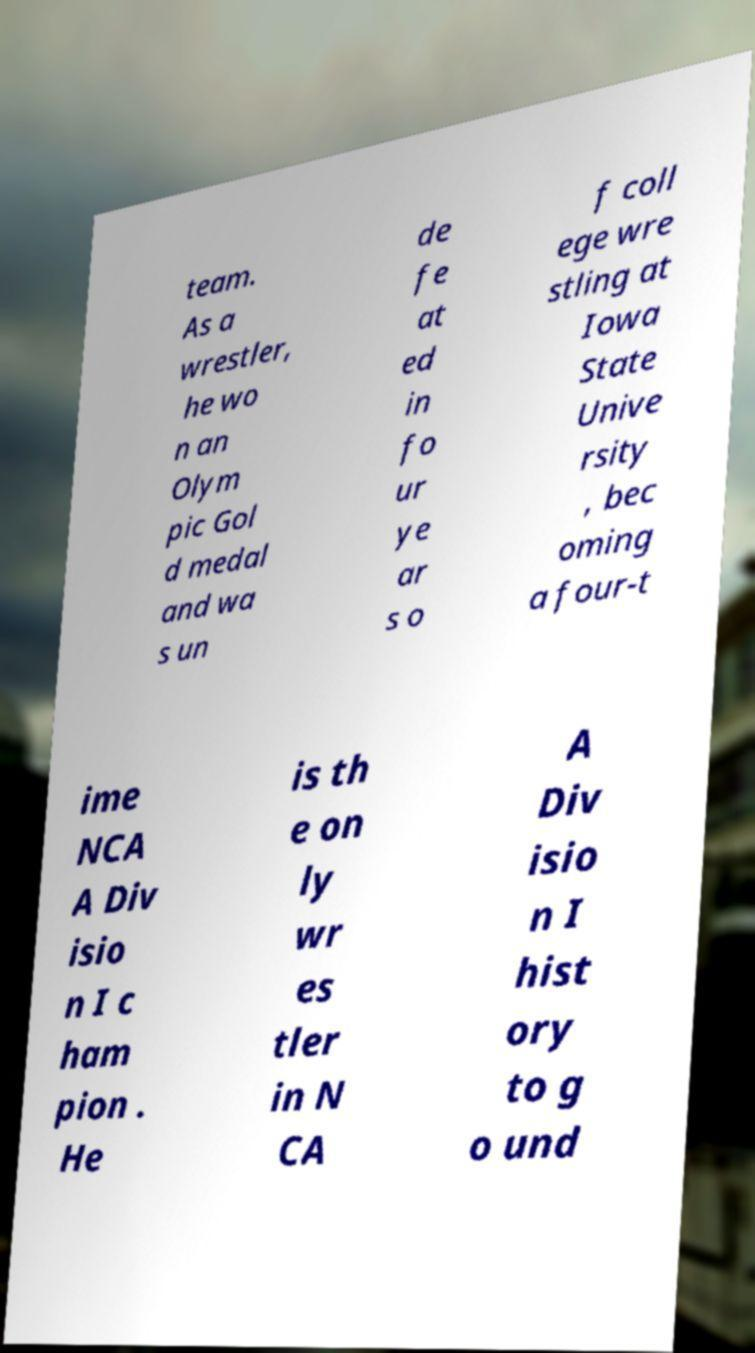There's text embedded in this image that I need extracted. Can you transcribe it verbatim? team. As a wrestler, he wo n an Olym pic Gol d medal and wa s un de fe at ed in fo ur ye ar s o f coll ege wre stling at Iowa State Unive rsity , bec oming a four-t ime NCA A Div isio n I c ham pion . He is th e on ly wr es tler in N CA A Div isio n I hist ory to g o und 